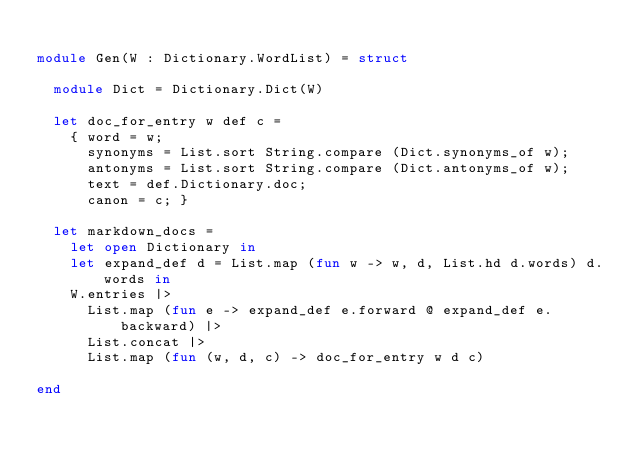Convert code to text. <code><loc_0><loc_0><loc_500><loc_500><_OCaml_>
module Gen(W : Dictionary.WordList) = struct

  module Dict = Dictionary.Dict(W)

  let doc_for_entry w def c =
    { word = w;
      synonyms = List.sort String.compare (Dict.synonyms_of w);
      antonyms = List.sort String.compare (Dict.antonyms_of w);
      text = def.Dictionary.doc;
      canon = c; }

  let markdown_docs =
    let open Dictionary in
    let expand_def d = List.map (fun w -> w, d, List.hd d.words) d.words in
    W.entries |>
      List.map (fun e -> expand_def e.forward @ expand_def e.backward) |>
      List.concat |>
      List.map (fun (w, d, c) -> doc_for_entry w d c)

end
</code> 